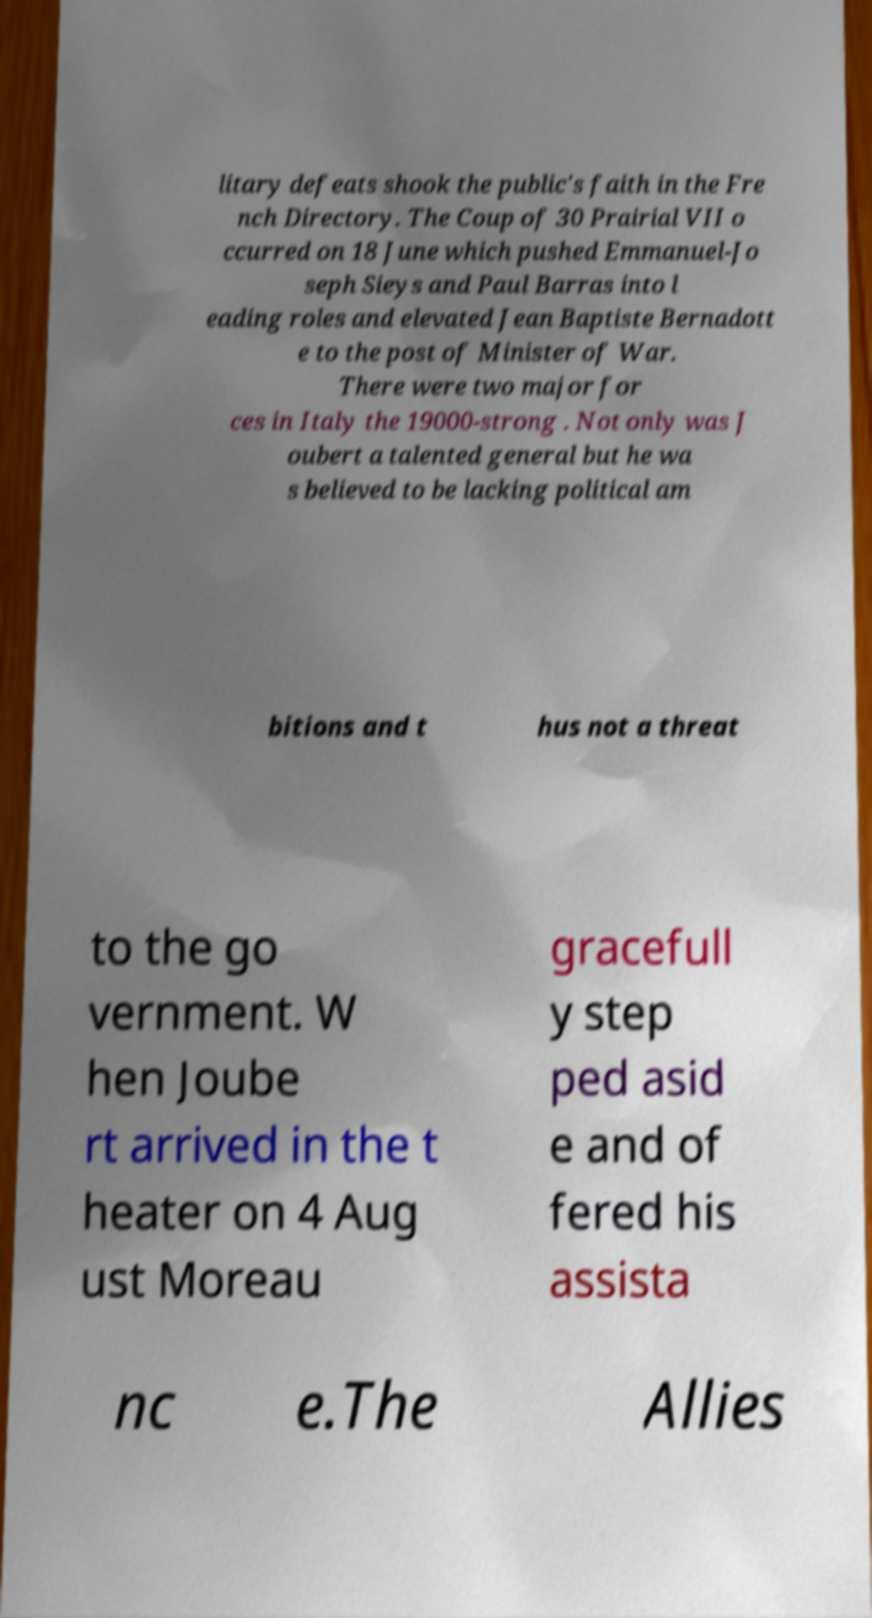Can you accurately transcribe the text from the provided image for me? litary defeats shook the public's faith in the Fre nch Directory. The Coup of 30 Prairial VII o ccurred on 18 June which pushed Emmanuel-Jo seph Sieys and Paul Barras into l eading roles and elevated Jean Baptiste Bernadott e to the post of Minister of War. There were two major for ces in Italy the 19000-strong . Not only was J oubert a talented general but he wa s believed to be lacking political am bitions and t hus not a threat to the go vernment. W hen Joube rt arrived in the t heater on 4 Aug ust Moreau gracefull y step ped asid e and of fered his assista nc e.The Allies 